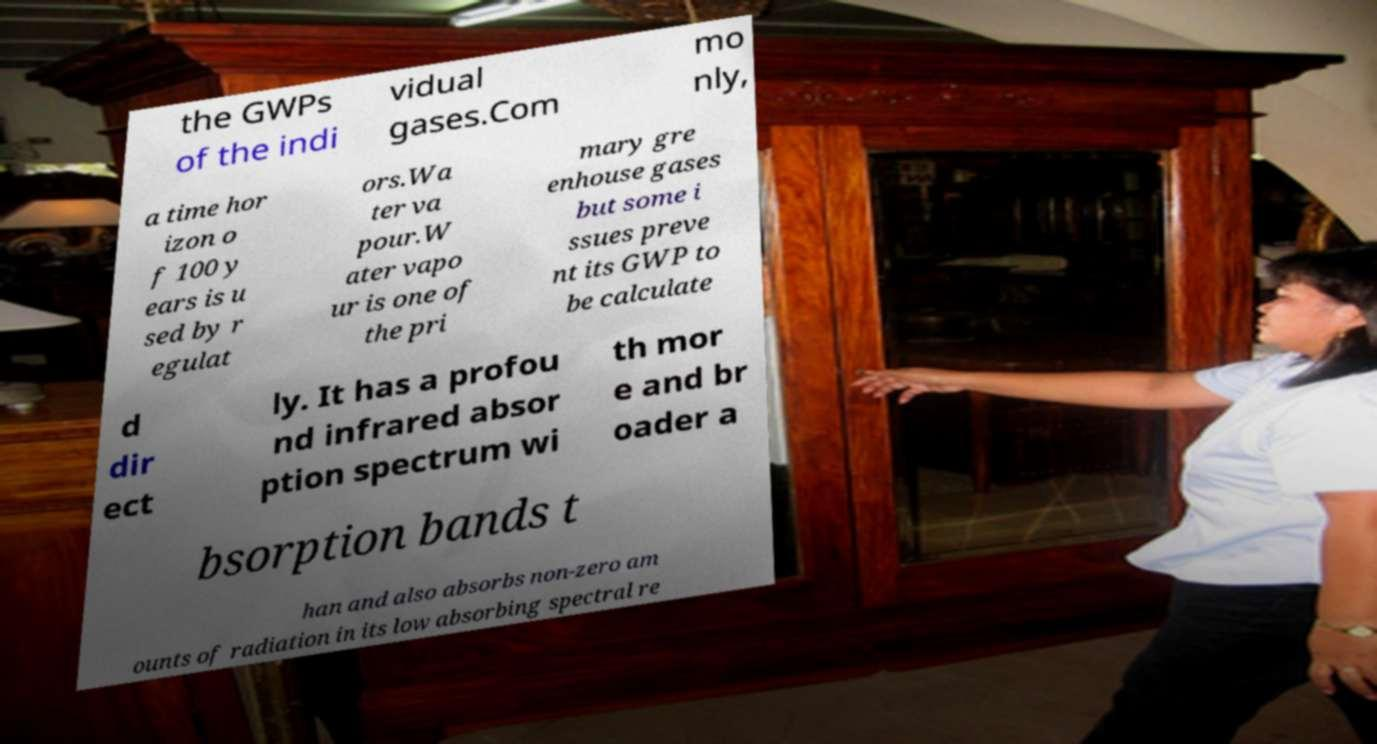There's text embedded in this image that I need extracted. Can you transcribe it verbatim? the GWPs of the indi vidual gases.Com mo nly, a time hor izon o f 100 y ears is u sed by r egulat ors.Wa ter va pour.W ater vapo ur is one of the pri mary gre enhouse gases but some i ssues preve nt its GWP to be calculate d dir ect ly. It has a profou nd infrared absor ption spectrum wi th mor e and br oader a bsorption bands t han and also absorbs non-zero am ounts of radiation in its low absorbing spectral re 